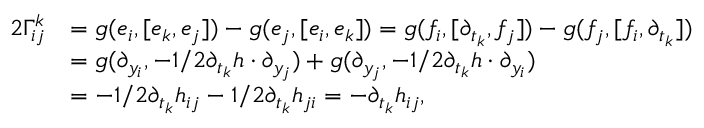<formula> <loc_0><loc_0><loc_500><loc_500>\begin{array} { r l } { 2 \Gamma _ { i j } ^ { k } } & { = g ( e _ { i } , [ e _ { k } , e _ { j } ] ) - g ( e _ { j } , [ e _ { i } , e _ { k } ] ) = g ( f _ { i } , [ \partial _ { t _ { k } } , f _ { j } ] ) - g ( f _ { j } , [ f _ { i } , \partial _ { t _ { k } } ] ) } \\ & { = g ( \partial _ { y _ { i } } , - 1 / 2 \partial _ { t _ { k } } h \cdot \partial _ { y _ { j } } ) + g ( \partial _ { y _ { j } } , - 1 / 2 \partial _ { t _ { k } } h \cdot \partial _ { y _ { i } } ) } \\ & { = - 1 / 2 \partial _ { t _ { k } } h _ { i j } - 1 / 2 \partial _ { t _ { k } } h _ { j i } = - \partial _ { t _ { k } } h _ { i j } , } \end{array}</formula> 